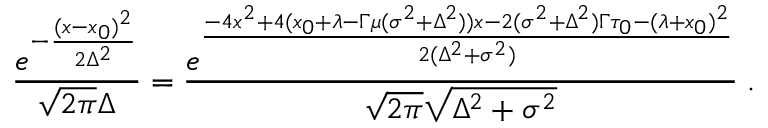Convert formula to latex. <formula><loc_0><loc_0><loc_500><loc_500>{ \frac { e ^ { - { \frac { ( x - x _ { 0 } ) ^ { 2 } } { 2 \Delta ^ { 2 } } } } } { \sqrt { 2 \pi } \Delta } } = { \frac { e ^ { \frac { - 4 x ^ { 2 } + 4 ( x _ { 0 } + \lambda - \Gamma \mu ( \sigma ^ { 2 } + \Delta ^ { 2 } ) ) x - 2 ( \sigma ^ { 2 } + \Delta ^ { 2 } ) \Gamma \tau _ { 0 } - ( \lambda + x _ { 0 } ) ^ { 2 } } { 2 ( \Delta ^ { 2 } + \sigma ^ { 2 } ) } } } { \sqrt { 2 \pi } \sqrt { \Delta ^ { 2 } + \sigma ^ { 2 } } } } \, .</formula> 